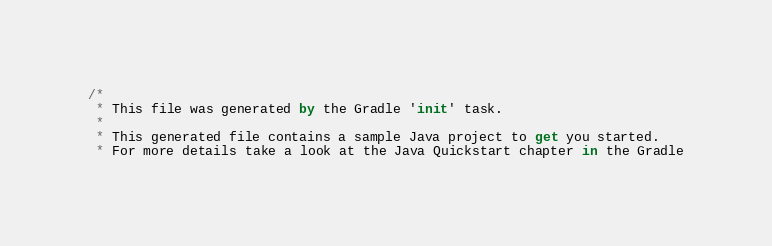<code> <loc_0><loc_0><loc_500><loc_500><_Kotlin_>/*
 * This file was generated by the Gradle 'init' task.
 *
 * This generated file contains a sample Java project to get you started.
 * For more details take a look at the Java Quickstart chapter in the Gradle</code> 